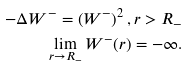Convert formula to latex. <formula><loc_0><loc_0><loc_500><loc_500>- \Delta W ^ { - } = \left ( W ^ { - } \right ) ^ { 2 } , r > R _ { - } \\ \lim _ { r \to R _ { - } } W ^ { - } ( r ) = - \infty .</formula> 